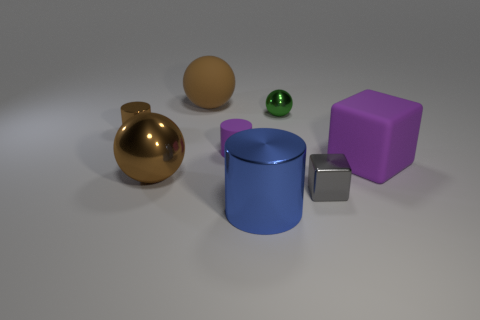Add 2 small purple things. How many objects exist? 10 Subtract all spheres. How many objects are left? 5 Subtract 0 gray balls. How many objects are left? 8 Subtract all purple cubes. Subtract all big blue matte spheres. How many objects are left? 7 Add 5 large objects. How many large objects are left? 9 Add 6 gray rubber cubes. How many gray rubber cubes exist? 6 